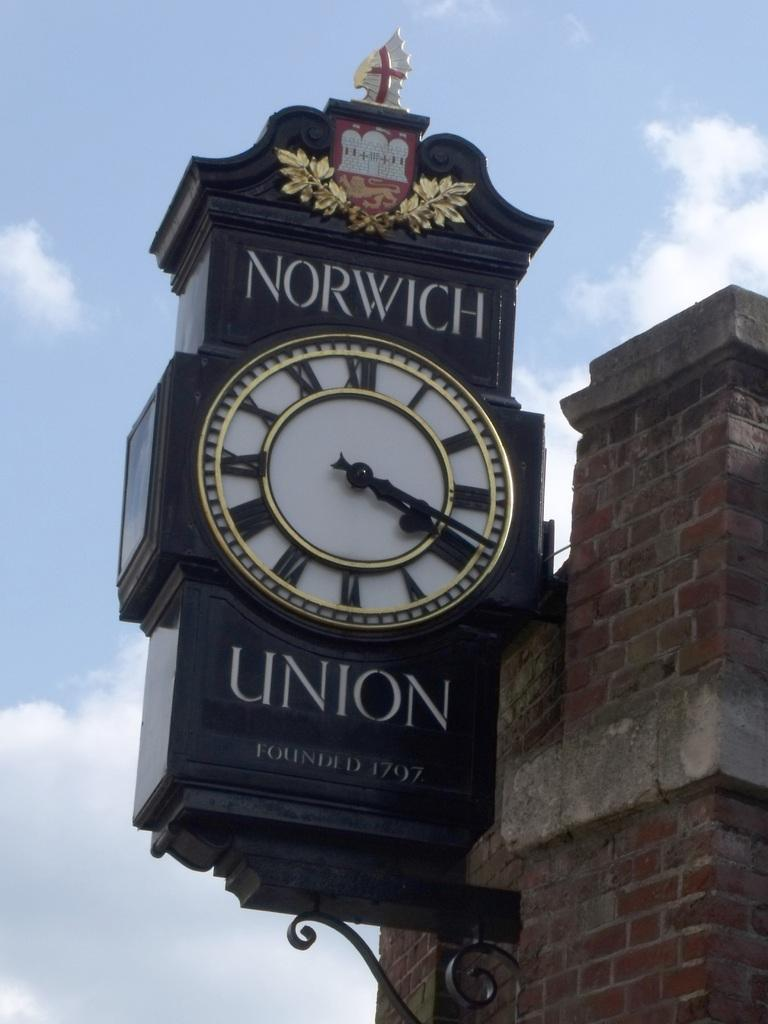<image>
Present a compact description of the photo's key features. The clock on the corner said it was 4:20 pm. 